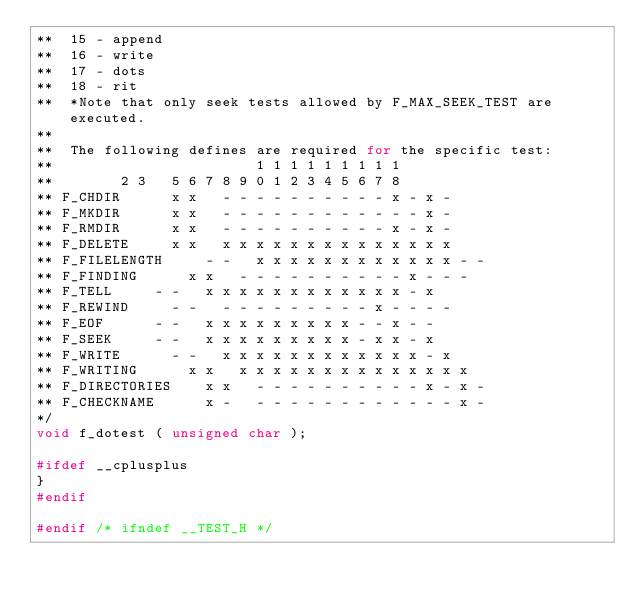<code> <loc_0><loc_0><loc_500><loc_500><_C_>**	15 - append
**	16 - write
**	17 - dots
**	18 - rit
**  *Note that only seek tests allowed by F_MAX_SEEK_TEST are executed.
**
**  The following defines are required for the specific test:
**			                  1 1 1 1 1 1 1 1 1
**			  2 3   5 6 7 8 9 0 1 2 3 4 5 6 7 8
** F_CHDIR		  x x   - - - - - - - - - - x - x -
** F_MKDIR		  x x   - - - - - - - - - - - - x -
** F_RMDIR		  x x   - - - - - - - - - - x - x -
** F_DELETE		  x x   x x x x x x x x x x x x x x
** F_FILELENGTH		  - -   x x x x x x x x x x x x - -
** F_FINDING		  x x   - - - - - - - - - - x - - -
** F_TELL		  - -   x x x x x x x x x x x x - x
** F_REWIND		  - -   - - - - - - - - - x - - - -
** F_EOF		  - -   x x x x x x x x x - - x - -
** F_SEEK		  - -   x x x x x x x x x - x x - x
** F_WRITE		  - -   x x x x x x x x x x x x - x
** F_WRITING		  x x   x x x x x x x x x x x x x x
** F_DIRECTORIES	  x x   - - - - - - - - - - x - x -
** F_CHECKNAME		  x -   - - - - - - - - - - - - x -
*/
void f_dotest ( unsigned char );

#ifdef __cplusplus
}
#endif

#endif /* ifndef __TEST_H */


</code> 